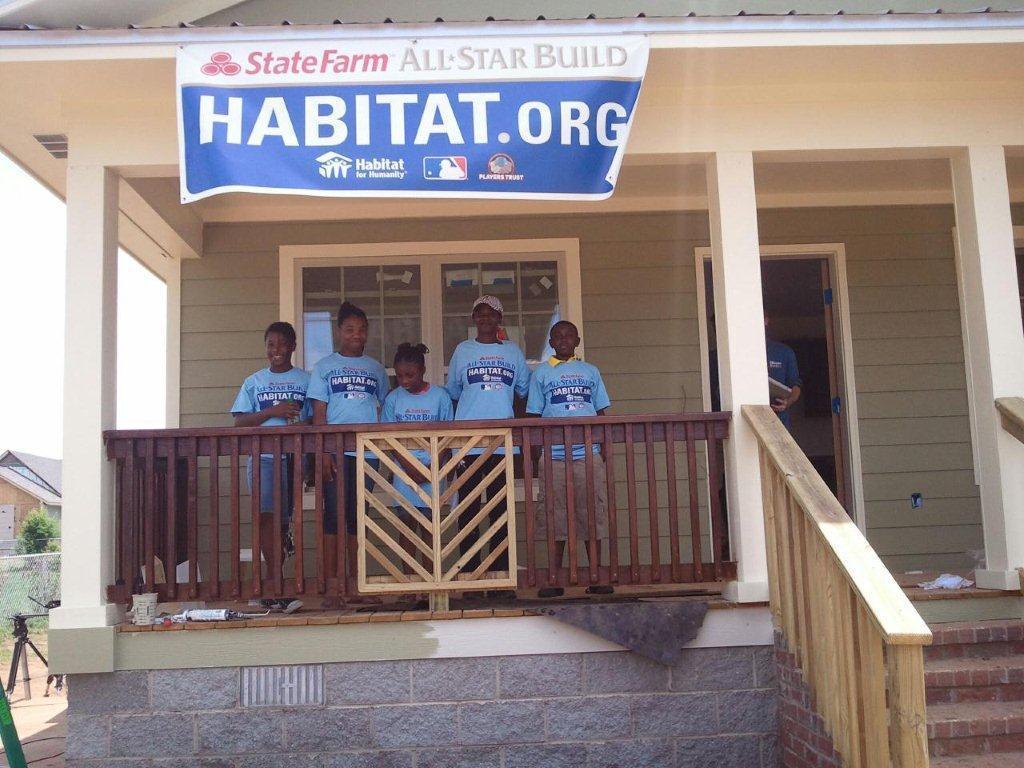Please provide a concise description of this image. In this image there is a house having staircase. There is a fence. Behind there are people standing on the floor having few objects. There is a banner attached to the wall. Right side there is a person holding an object. Left side there are objects on the land. Behind there is a fence. Behind there is a tree and a house. Left side there is sky. 